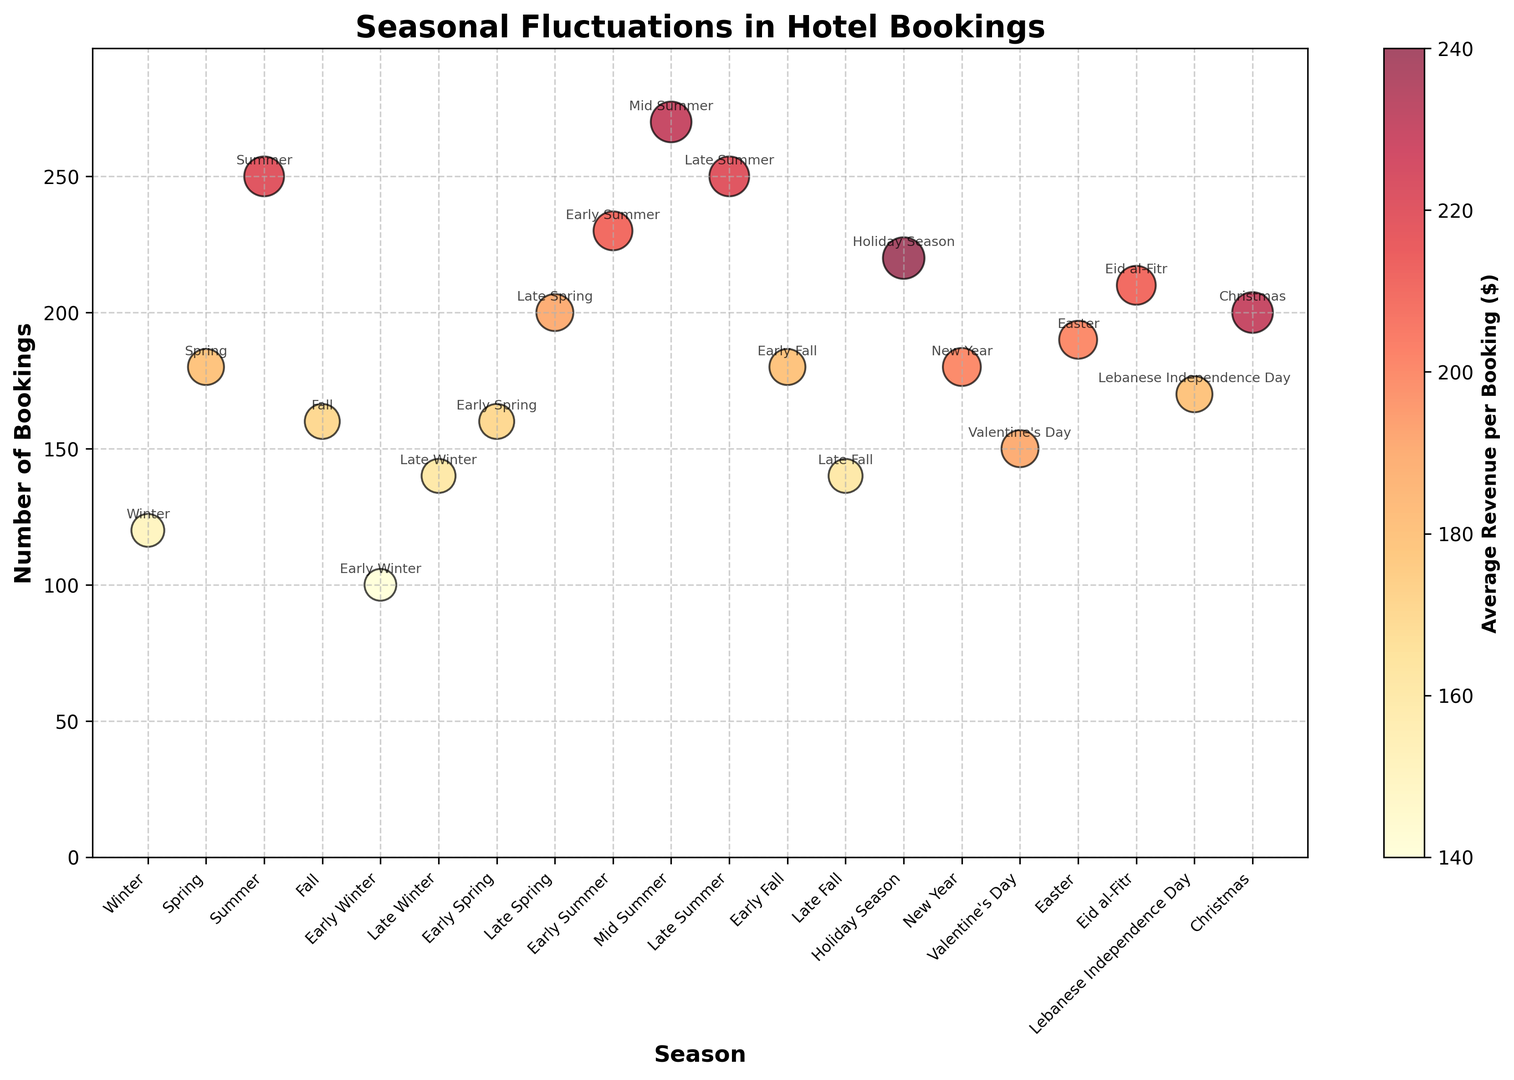What's the season with the highest number of bookings? The number of bookings is represented on the y-axis. The season with the highest y-value is Mid Summer with 270 bookings.
Answer: Mid Summer Which season has the highest average revenue per booking and how is it represented visually? The average revenue is represented by the size and color of the bubbles. The largest and most intensely colored bubble, indicating the highest revenue, occurs during the Holiday Season, which has an average revenue of $240 per booking.
Answer: Holiday Season Compare Early Winter and Early Spring bookings. Which season has more bookings and by how much? Early Winter has 100 bookings and Early Spring has 160 bookings. To find the difference: 160 - 100 = 60. Early Spring has 60 more bookings than Early Winter.
Answer: Early Spring by 60 What is the sum of bookings in all the winter-related seasons (Winter, Early Winter, Late Winter, Holiday Season, New Year)? Winter has 120 bookings, Early Winter 100, Late Winter 140, Holiday Season 220, and New Year 180. Summing these: 120 + 100 + 140 + 220 + 180 = 760.
Answer: 760 Which season, Christmas or Easter, has a higher average revenue per booking, and what are the respective values? The average revenue for Christmas is $230 per booking, and for Easter, it is $200 per booking. Comparing the two values, Christmas has a higher average revenue.
Answer: Christmas, $230 By how much does the average revenue per booking in Mid Summer differ from that in New Year? The average revenue per booking in Mid Summer is $230, and in New Year, it is $200. The difference is calculated as $230 - $200 = $30.
Answer: $30 What's the relation between the number of bookings and average revenue during Valentine's Day compared to Lebanese Independence Day? Valentine's Day has 150 bookings and an average revenue of $190, while Lebanese Independence Day has 170 bookings and an average revenue of $180. Valentine's Day has fewer bookings but a higher average revenue compared to Lebanese Independence Day.
Answer: Fewer bookings but higher revenue on Valentine’s Day During which season does the number of bookings steeply increase, comparing Early Summer to Mid Summer? Early Summer has 230 bookings, and Mid Summer has 270 bookings. The increase is steep as the number of bookings rises by 40 (270 - 230).
Answer: From Early Summer to Mid Summer What's the average number of bookings across the four main seasons (Winter, Spring, Summer, Fall)? Winter has 120 bookings, Spring 180, Summer 250, Fall 160. Sum them: 120 + 180 + 250 + 160 = 710. Average: 710 / 4 = 177.5.
Answer: 177.5 